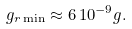<formula> <loc_0><loc_0><loc_500><loc_500>g _ { r \min } \approx 6 \, 1 0 ^ { - 9 } g .</formula> 